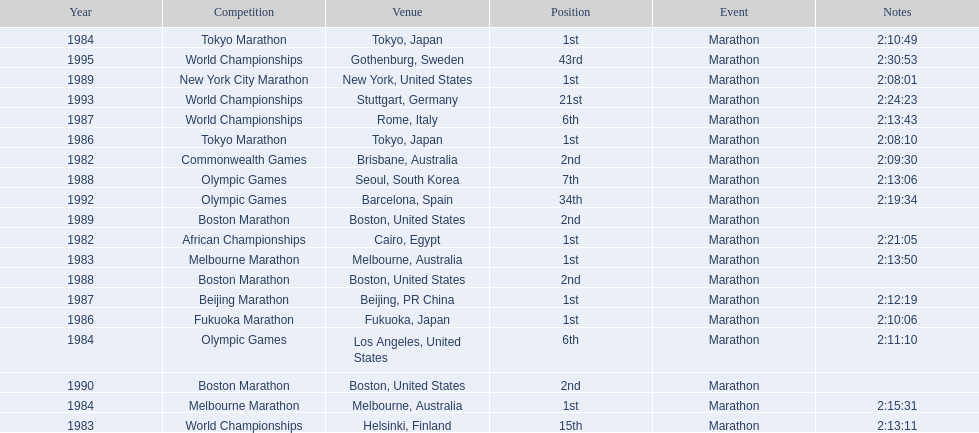What are the competitions? African Championships, Cairo, Egypt, Commonwealth Games, Brisbane, Australia, World Championships, Helsinki, Finland, Melbourne Marathon, Melbourne, Australia, Tokyo Marathon, Tokyo, Japan, Olympic Games, Los Angeles, United States, Melbourne Marathon, Melbourne, Australia, Tokyo Marathon, Tokyo, Japan, Fukuoka Marathon, Fukuoka, Japan, World Championships, Rome, Italy, Beijing Marathon, Beijing, PR China, Olympic Games, Seoul, South Korea, Boston Marathon, Boston, United States, New York City Marathon, New York, United States, Boston Marathon, Boston, United States, Boston Marathon, Boston, United States, Olympic Games, Barcelona, Spain, World Championships, Stuttgart, Germany, World Championships, Gothenburg, Sweden. Which ones occured in china? Beijing Marathon, Beijing, PR China. Which one is it? Beijing Marathon. 